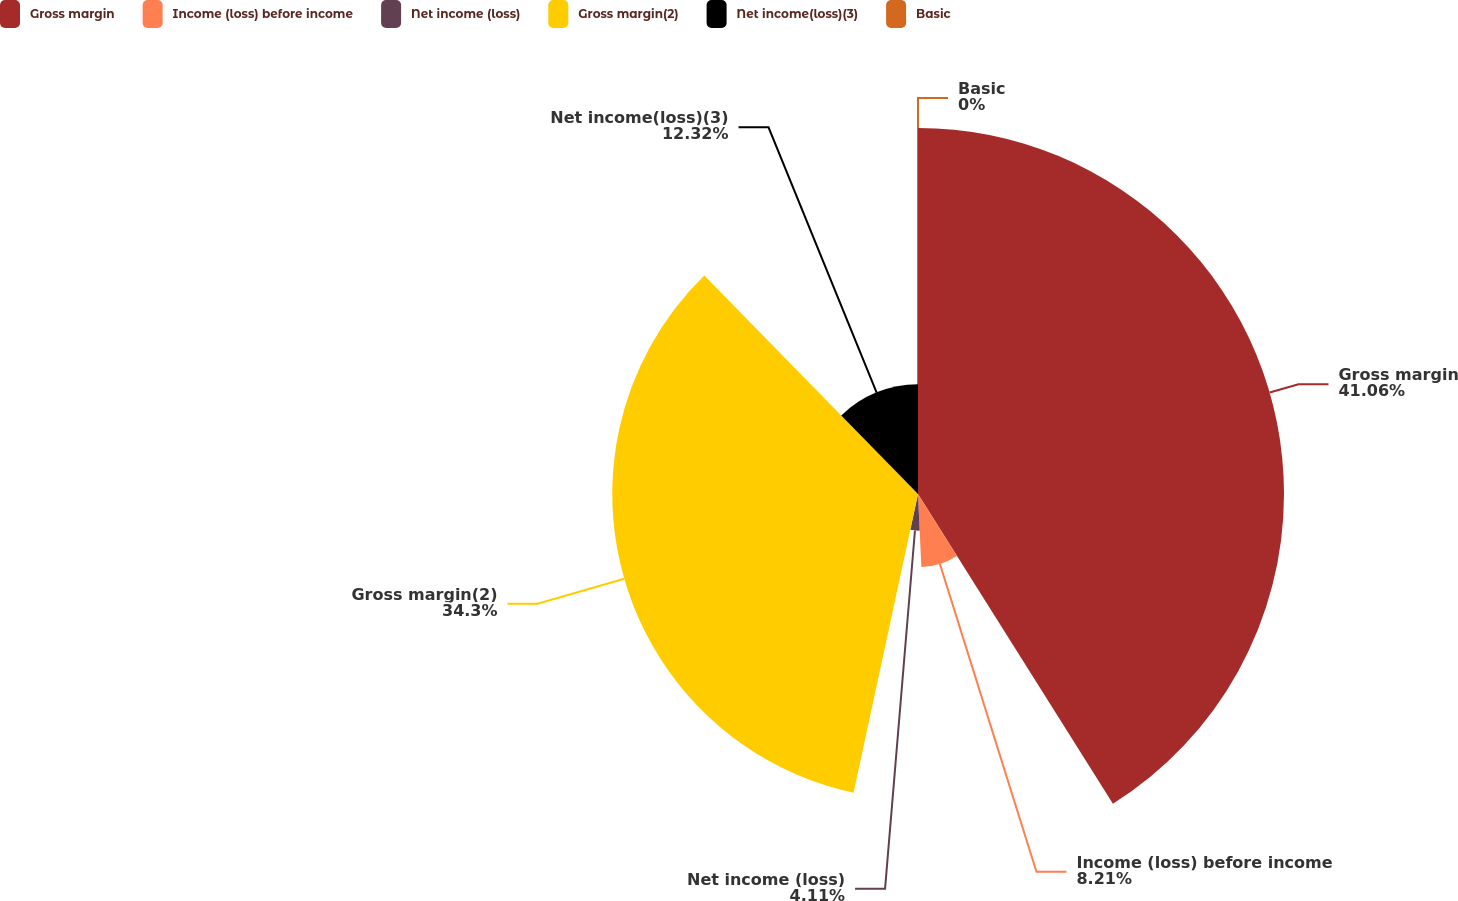<chart> <loc_0><loc_0><loc_500><loc_500><pie_chart><fcel>Gross margin<fcel>Income (loss) before income<fcel>Net income (loss)<fcel>Gross margin(2)<fcel>Net income(loss)(3)<fcel>Basic<nl><fcel>41.06%<fcel>8.21%<fcel>4.11%<fcel>34.3%<fcel>12.32%<fcel>0.0%<nl></chart> 